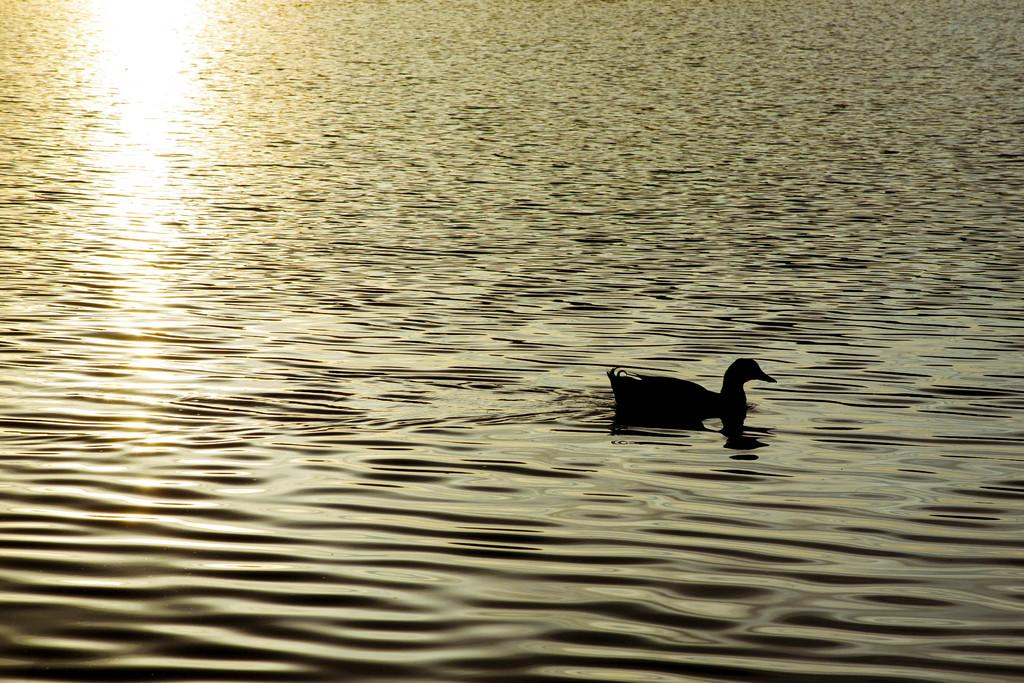Where was the image taken? The image is taken outdoors. What can be seen at the bottom of the image? There is a river with water at the bottom of the image. What animal is present in the river in the middle of the image? A duck is swimming in the river in the middle of the image. What type of curtain can be seen hanging from the trees in the image? There are no curtains present in the image; it features a river with a duck swimming in it. 